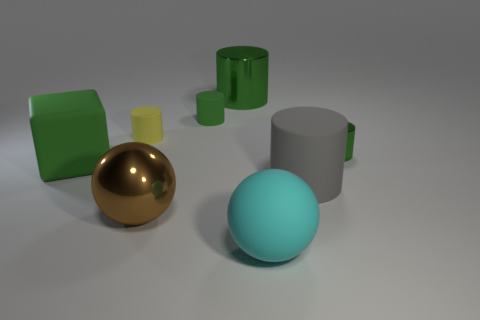How many green cylinders must be subtracted to get 1 green cylinders? 2 Subtract all gray spheres. How many green cylinders are left? 3 Subtract 2 cylinders. How many cylinders are left? 3 Subtract all purple cylinders. Subtract all brown cubes. How many cylinders are left? 5 Add 2 large gray metal cubes. How many objects exist? 10 Subtract all cubes. How many objects are left? 7 Subtract all tiny yellow metal cylinders. Subtract all big green rubber things. How many objects are left? 7 Add 1 big brown balls. How many big brown balls are left? 2 Add 1 green matte cylinders. How many green matte cylinders exist? 2 Subtract 0 red cubes. How many objects are left? 8 